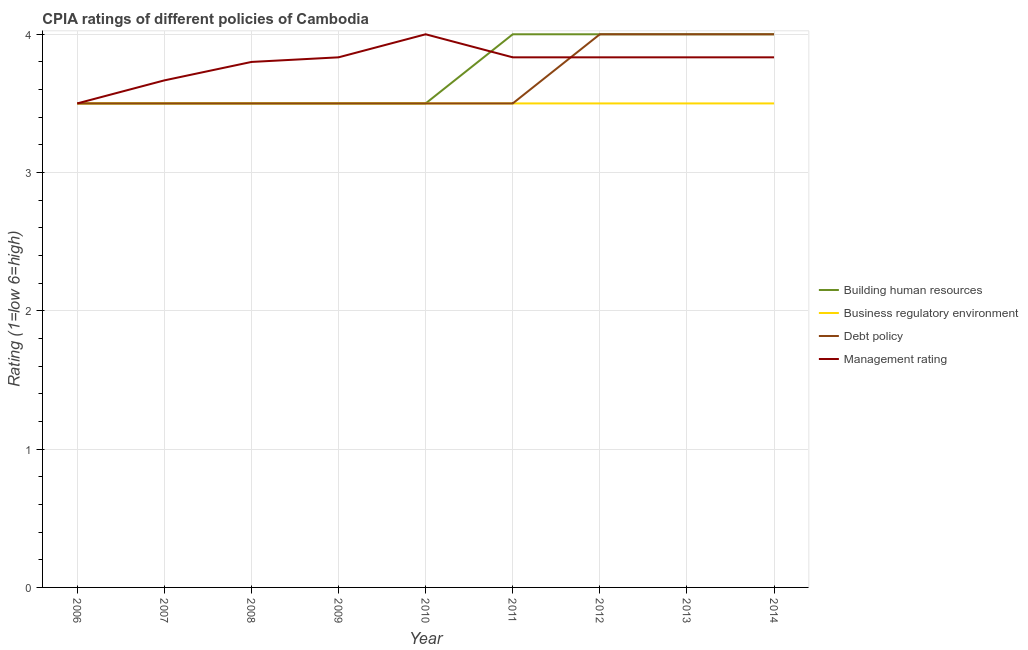How many different coloured lines are there?
Make the answer very short. 4. Is the number of lines equal to the number of legend labels?
Offer a terse response. Yes. What is the cpia rating of management in 2013?
Ensure brevity in your answer.  3.83. Across all years, what is the minimum cpia rating of debt policy?
Your answer should be very brief. 3.5. In which year was the cpia rating of management maximum?
Offer a terse response. 2010. What is the total cpia rating of building human resources in the graph?
Keep it short and to the point. 33.5. What is the difference between the cpia rating of debt policy in 2008 and that in 2013?
Your answer should be very brief. -0.5. What is the average cpia rating of debt policy per year?
Provide a succinct answer. 3.67. In the year 2007, what is the difference between the cpia rating of management and cpia rating of debt policy?
Your answer should be compact. 0.17. What is the ratio of the cpia rating of management in 2006 to that in 2008?
Keep it short and to the point. 0.92. Is the cpia rating of debt policy in 2006 less than that in 2009?
Give a very brief answer. No. Is the difference between the cpia rating of building human resources in 2009 and 2012 greater than the difference between the cpia rating of management in 2009 and 2012?
Your answer should be compact. No. What is the difference between the highest and the second highest cpia rating of building human resources?
Offer a terse response. 0. What is the difference between the highest and the lowest cpia rating of debt policy?
Your response must be concise. 0.5. Is the sum of the cpia rating of management in 2007 and 2009 greater than the maximum cpia rating of business regulatory environment across all years?
Offer a terse response. Yes. Is it the case that in every year, the sum of the cpia rating of building human resources and cpia rating of business regulatory environment is greater than the cpia rating of debt policy?
Your answer should be compact. Yes. Does the cpia rating of building human resources monotonically increase over the years?
Provide a succinct answer. No. Is the cpia rating of business regulatory environment strictly less than the cpia rating of building human resources over the years?
Offer a terse response. No. How many years are there in the graph?
Your answer should be compact. 9. Does the graph contain any zero values?
Provide a succinct answer. No. Where does the legend appear in the graph?
Your response must be concise. Center right. How many legend labels are there?
Your response must be concise. 4. How are the legend labels stacked?
Offer a very short reply. Vertical. What is the title of the graph?
Keep it short and to the point. CPIA ratings of different policies of Cambodia. Does "WFP" appear as one of the legend labels in the graph?
Ensure brevity in your answer.  No. What is the label or title of the X-axis?
Your answer should be compact. Year. What is the Rating (1=low 6=high) of Business regulatory environment in 2006?
Offer a terse response. 3.5. What is the Rating (1=low 6=high) of Business regulatory environment in 2007?
Offer a terse response. 3.5. What is the Rating (1=low 6=high) in Debt policy in 2007?
Provide a short and direct response. 3.5. What is the Rating (1=low 6=high) of Management rating in 2007?
Your answer should be compact. 3.67. What is the Rating (1=low 6=high) of Building human resources in 2008?
Give a very brief answer. 3.5. What is the Rating (1=low 6=high) in Business regulatory environment in 2008?
Offer a terse response. 3.5. What is the Rating (1=low 6=high) of Debt policy in 2008?
Keep it short and to the point. 3.5. What is the Rating (1=low 6=high) of Management rating in 2008?
Your answer should be compact. 3.8. What is the Rating (1=low 6=high) in Building human resources in 2009?
Provide a short and direct response. 3.5. What is the Rating (1=low 6=high) of Debt policy in 2009?
Your answer should be very brief. 3.5. What is the Rating (1=low 6=high) of Management rating in 2009?
Offer a terse response. 3.83. What is the Rating (1=low 6=high) of Debt policy in 2010?
Provide a succinct answer. 3.5. What is the Rating (1=low 6=high) of Business regulatory environment in 2011?
Your answer should be very brief. 3.5. What is the Rating (1=low 6=high) of Debt policy in 2011?
Your answer should be very brief. 3.5. What is the Rating (1=low 6=high) of Management rating in 2011?
Your answer should be very brief. 3.83. What is the Rating (1=low 6=high) of Building human resources in 2012?
Keep it short and to the point. 4. What is the Rating (1=low 6=high) in Business regulatory environment in 2012?
Ensure brevity in your answer.  3.5. What is the Rating (1=low 6=high) in Debt policy in 2012?
Keep it short and to the point. 4. What is the Rating (1=low 6=high) of Management rating in 2012?
Provide a succinct answer. 3.83. What is the Rating (1=low 6=high) in Building human resources in 2013?
Your answer should be very brief. 4. What is the Rating (1=low 6=high) in Business regulatory environment in 2013?
Ensure brevity in your answer.  3.5. What is the Rating (1=low 6=high) of Debt policy in 2013?
Your response must be concise. 4. What is the Rating (1=low 6=high) in Management rating in 2013?
Give a very brief answer. 3.83. What is the Rating (1=low 6=high) in Building human resources in 2014?
Offer a very short reply. 4. What is the Rating (1=low 6=high) in Debt policy in 2014?
Your answer should be very brief. 4. What is the Rating (1=low 6=high) of Management rating in 2014?
Your response must be concise. 3.83. Across all years, what is the maximum Rating (1=low 6=high) of Business regulatory environment?
Ensure brevity in your answer.  3.5. Across all years, what is the maximum Rating (1=low 6=high) of Debt policy?
Offer a very short reply. 4. Across all years, what is the maximum Rating (1=low 6=high) of Management rating?
Ensure brevity in your answer.  4. Across all years, what is the minimum Rating (1=low 6=high) of Building human resources?
Make the answer very short. 3.5. Across all years, what is the minimum Rating (1=low 6=high) in Business regulatory environment?
Offer a terse response. 3.5. Across all years, what is the minimum Rating (1=low 6=high) of Debt policy?
Keep it short and to the point. 3.5. What is the total Rating (1=low 6=high) in Building human resources in the graph?
Keep it short and to the point. 33.5. What is the total Rating (1=low 6=high) in Business regulatory environment in the graph?
Your answer should be very brief. 31.5. What is the total Rating (1=low 6=high) of Management rating in the graph?
Give a very brief answer. 34.13. What is the difference between the Rating (1=low 6=high) of Building human resources in 2006 and that in 2007?
Keep it short and to the point. 0. What is the difference between the Rating (1=low 6=high) in Business regulatory environment in 2006 and that in 2007?
Offer a terse response. 0. What is the difference between the Rating (1=low 6=high) of Management rating in 2006 and that in 2007?
Your answer should be compact. -0.17. What is the difference between the Rating (1=low 6=high) of Business regulatory environment in 2006 and that in 2008?
Keep it short and to the point. 0. What is the difference between the Rating (1=low 6=high) in Debt policy in 2006 and that in 2008?
Provide a short and direct response. 0. What is the difference between the Rating (1=low 6=high) of Building human resources in 2006 and that in 2009?
Give a very brief answer. 0. What is the difference between the Rating (1=low 6=high) in Business regulatory environment in 2006 and that in 2009?
Make the answer very short. 0. What is the difference between the Rating (1=low 6=high) of Business regulatory environment in 2006 and that in 2010?
Keep it short and to the point. 0. What is the difference between the Rating (1=low 6=high) in Debt policy in 2006 and that in 2010?
Make the answer very short. 0. What is the difference between the Rating (1=low 6=high) of Management rating in 2006 and that in 2010?
Provide a short and direct response. -0.5. What is the difference between the Rating (1=low 6=high) in Building human resources in 2006 and that in 2011?
Ensure brevity in your answer.  -0.5. What is the difference between the Rating (1=low 6=high) in Debt policy in 2006 and that in 2011?
Make the answer very short. 0. What is the difference between the Rating (1=low 6=high) of Debt policy in 2006 and that in 2012?
Offer a very short reply. -0.5. What is the difference between the Rating (1=low 6=high) of Management rating in 2006 and that in 2012?
Your response must be concise. -0.33. What is the difference between the Rating (1=low 6=high) of Debt policy in 2006 and that in 2013?
Your answer should be compact. -0.5. What is the difference between the Rating (1=low 6=high) of Management rating in 2006 and that in 2014?
Your response must be concise. -0.33. What is the difference between the Rating (1=low 6=high) in Building human resources in 2007 and that in 2008?
Give a very brief answer. 0. What is the difference between the Rating (1=low 6=high) in Debt policy in 2007 and that in 2008?
Your response must be concise. 0. What is the difference between the Rating (1=low 6=high) in Management rating in 2007 and that in 2008?
Provide a succinct answer. -0.13. What is the difference between the Rating (1=low 6=high) in Debt policy in 2007 and that in 2009?
Your answer should be very brief. 0. What is the difference between the Rating (1=low 6=high) in Building human resources in 2007 and that in 2010?
Keep it short and to the point. 0. What is the difference between the Rating (1=low 6=high) of Management rating in 2007 and that in 2010?
Your answer should be compact. -0.33. What is the difference between the Rating (1=low 6=high) of Business regulatory environment in 2007 and that in 2011?
Keep it short and to the point. 0. What is the difference between the Rating (1=low 6=high) in Debt policy in 2007 and that in 2011?
Provide a succinct answer. 0. What is the difference between the Rating (1=low 6=high) in Management rating in 2007 and that in 2011?
Your answer should be very brief. -0.17. What is the difference between the Rating (1=low 6=high) of Business regulatory environment in 2007 and that in 2012?
Offer a very short reply. 0. What is the difference between the Rating (1=low 6=high) of Debt policy in 2007 and that in 2012?
Your answer should be very brief. -0.5. What is the difference between the Rating (1=low 6=high) of Management rating in 2007 and that in 2012?
Provide a succinct answer. -0.17. What is the difference between the Rating (1=low 6=high) of Building human resources in 2007 and that in 2013?
Keep it short and to the point. -0.5. What is the difference between the Rating (1=low 6=high) of Building human resources in 2007 and that in 2014?
Provide a short and direct response. -0.5. What is the difference between the Rating (1=low 6=high) of Business regulatory environment in 2007 and that in 2014?
Ensure brevity in your answer.  0. What is the difference between the Rating (1=low 6=high) of Debt policy in 2007 and that in 2014?
Offer a very short reply. -0.5. What is the difference between the Rating (1=low 6=high) in Business regulatory environment in 2008 and that in 2009?
Make the answer very short. 0. What is the difference between the Rating (1=low 6=high) in Debt policy in 2008 and that in 2009?
Your response must be concise. 0. What is the difference between the Rating (1=low 6=high) in Management rating in 2008 and that in 2009?
Your answer should be very brief. -0.03. What is the difference between the Rating (1=low 6=high) of Building human resources in 2008 and that in 2010?
Provide a succinct answer. 0. What is the difference between the Rating (1=low 6=high) of Debt policy in 2008 and that in 2010?
Your answer should be very brief. 0. What is the difference between the Rating (1=low 6=high) of Management rating in 2008 and that in 2010?
Give a very brief answer. -0.2. What is the difference between the Rating (1=low 6=high) of Business regulatory environment in 2008 and that in 2011?
Make the answer very short. 0. What is the difference between the Rating (1=low 6=high) of Management rating in 2008 and that in 2011?
Provide a short and direct response. -0.03. What is the difference between the Rating (1=low 6=high) in Building human resources in 2008 and that in 2012?
Your response must be concise. -0.5. What is the difference between the Rating (1=low 6=high) in Business regulatory environment in 2008 and that in 2012?
Your response must be concise. 0. What is the difference between the Rating (1=low 6=high) of Management rating in 2008 and that in 2012?
Offer a terse response. -0.03. What is the difference between the Rating (1=low 6=high) of Management rating in 2008 and that in 2013?
Your response must be concise. -0.03. What is the difference between the Rating (1=low 6=high) of Management rating in 2008 and that in 2014?
Provide a succinct answer. -0.03. What is the difference between the Rating (1=low 6=high) of Building human resources in 2009 and that in 2010?
Your answer should be compact. 0. What is the difference between the Rating (1=low 6=high) of Business regulatory environment in 2009 and that in 2010?
Your answer should be compact. 0. What is the difference between the Rating (1=low 6=high) in Debt policy in 2009 and that in 2010?
Provide a succinct answer. 0. What is the difference between the Rating (1=low 6=high) of Management rating in 2009 and that in 2010?
Offer a very short reply. -0.17. What is the difference between the Rating (1=low 6=high) in Building human resources in 2009 and that in 2011?
Offer a terse response. -0.5. What is the difference between the Rating (1=low 6=high) in Business regulatory environment in 2009 and that in 2011?
Give a very brief answer. 0. What is the difference between the Rating (1=low 6=high) of Building human resources in 2009 and that in 2012?
Offer a very short reply. -0.5. What is the difference between the Rating (1=low 6=high) in Business regulatory environment in 2009 and that in 2013?
Offer a terse response. 0. What is the difference between the Rating (1=low 6=high) in Business regulatory environment in 2009 and that in 2014?
Ensure brevity in your answer.  0. What is the difference between the Rating (1=low 6=high) of Management rating in 2010 and that in 2011?
Your answer should be compact. 0.17. What is the difference between the Rating (1=low 6=high) of Building human resources in 2010 and that in 2012?
Offer a very short reply. -0.5. What is the difference between the Rating (1=low 6=high) in Business regulatory environment in 2010 and that in 2012?
Your answer should be compact. 0. What is the difference between the Rating (1=low 6=high) of Debt policy in 2010 and that in 2012?
Your answer should be very brief. -0.5. What is the difference between the Rating (1=low 6=high) in Management rating in 2010 and that in 2012?
Offer a very short reply. 0.17. What is the difference between the Rating (1=low 6=high) in Debt policy in 2010 and that in 2013?
Make the answer very short. -0.5. What is the difference between the Rating (1=low 6=high) in Management rating in 2010 and that in 2013?
Your answer should be compact. 0.17. What is the difference between the Rating (1=low 6=high) in Business regulatory environment in 2010 and that in 2014?
Offer a very short reply. 0. What is the difference between the Rating (1=low 6=high) in Management rating in 2010 and that in 2014?
Ensure brevity in your answer.  0.17. What is the difference between the Rating (1=low 6=high) of Business regulatory environment in 2011 and that in 2012?
Make the answer very short. 0. What is the difference between the Rating (1=low 6=high) in Debt policy in 2011 and that in 2012?
Offer a very short reply. -0.5. What is the difference between the Rating (1=low 6=high) in Building human resources in 2011 and that in 2013?
Make the answer very short. 0. What is the difference between the Rating (1=low 6=high) in Business regulatory environment in 2011 and that in 2013?
Give a very brief answer. 0. What is the difference between the Rating (1=low 6=high) of Debt policy in 2011 and that in 2013?
Make the answer very short. -0.5. What is the difference between the Rating (1=low 6=high) of Management rating in 2011 and that in 2013?
Provide a succinct answer. 0. What is the difference between the Rating (1=low 6=high) of Building human resources in 2012 and that in 2013?
Offer a very short reply. 0. What is the difference between the Rating (1=low 6=high) in Business regulatory environment in 2012 and that in 2013?
Give a very brief answer. 0. What is the difference between the Rating (1=low 6=high) of Debt policy in 2012 and that in 2013?
Ensure brevity in your answer.  0. What is the difference between the Rating (1=low 6=high) of Management rating in 2012 and that in 2013?
Your response must be concise. 0. What is the difference between the Rating (1=low 6=high) of Building human resources in 2012 and that in 2014?
Give a very brief answer. 0. What is the difference between the Rating (1=low 6=high) of Business regulatory environment in 2012 and that in 2014?
Your response must be concise. 0. What is the difference between the Rating (1=low 6=high) in Building human resources in 2013 and that in 2014?
Provide a succinct answer. 0. What is the difference between the Rating (1=low 6=high) of Business regulatory environment in 2013 and that in 2014?
Keep it short and to the point. 0. What is the difference between the Rating (1=low 6=high) in Management rating in 2013 and that in 2014?
Keep it short and to the point. 0. What is the difference between the Rating (1=low 6=high) of Building human resources in 2006 and the Rating (1=low 6=high) of Business regulatory environment in 2007?
Your response must be concise. 0. What is the difference between the Rating (1=low 6=high) in Building human resources in 2006 and the Rating (1=low 6=high) in Management rating in 2007?
Ensure brevity in your answer.  -0.17. What is the difference between the Rating (1=low 6=high) of Debt policy in 2006 and the Rating (1=low 6=high) of Management rating in 2007?
Give a very brief answer. -0.17. What is the difference between the Rating (1=low 6=high) of Business regulatory environment in 2006 and the Rating (1=low 6=high) of Debt policy in 2008?
Provide a short and direct response. 0. What is the difference between the Rating (1=low 6=high) of Business regulatory environment in 2006 and the Rating (1=low 6=high) of Management rating in 2008?
Offer a very short reply. -0.3. What is the difference between the Rating (1=low 6=high) of Debt policy in 2006 and the Rating (1=low 6=high) of Management rating in 2008?
Your answer should be very brief. -0.3. What is the difference between the Rating (1=low 6=high) of Building human resources in 2006 and the Rating (1=low 6=high) of Business regulatory environment in 2009?
Offer a terse response. 0. What is the difference between the Rating (1=low 6=high) of Building human resources in 2006 and the Rating (1=low 6=high) of Management rating in 2009?
Make the answer very short. -0.33. What is the difference between the Rating (1=low 6=high) of Debt policy in 2006 and the Rating (1=low 6=high) of Management rating in 2009?
Provide a short and direct response. -0.33. What is the difference between the Rating (1=low 6=high) of Building human resources in 2006 and the Rating (1=low 6=high) of Business regulatory environment in 2010?
Your answer should be very brief. 0. What is the difference between the Rating (1=low 6=high) of Building human resources in 2006 and the Rating (1=low 6=high) of Debt policy in 2010?
Give a very brief answer. 0. What is the difference between the Rating (1=low 6=high) in Building human resources in 2006 and the Rating (1=low 6=high) in Management rating in 2010?
Provide a succinct answer. -0.5. What is the difference between the Rating (1=low 6=high) in Business regulatory environment in 2006 and the Rating (1=low 6=high) in Debt policy in 2010?
Offer a very short reply. 0. What is the difference between the Rating (1=low 6=high) in Business regulatory environment in 2006 and the Rating (1=low 6=high) in Management rating in 2010?
Provide a short and direct response. -0.5. What is the difference between the Rating (1=low 6=high) of Debt policy in 2006 and the Rating (1=low 6=high) of Management rating in 2010?
Give a very brief answer. -0.5. What is the difference between the Rating (1=low 6=high) of Building human resources in 2006 and the Rating (1=low 6=high) of Business regulatory environment in 2011?
Your answer should be compact. 0. What is the difference between the Rating (1=low 6=high) in Building human resources in 2006 and the Rating (1=low 6=high) in Debt policy in 2011?
Provide a succinct answer. 0. What is the difference between the Rating (1=low 6=high) in Debt policy in 2006 and the Rating (1=low 6=high) in Management rating in 2012?
Your response must be concise. -0.33. What is the difference between the Rating (1=low 6=high) of Building human resources in 2006 and the Rating (1=low 6=high) of Debt policy in 2013?
Give a very brief answer. -0.5. What is the difference between the Rating (1=low 6=high) of Building human resources in 2006 and the Rating (1=low 6=high) of Management rating in 2013?
Ensure brevity in your answer.  -0.33. What is the difference between the Rating (1=low 6=high) of Business regulatory environment in 2006 and the Rating (1=low 6=high) of Debt policy in 2013?
Ensure brevity in your answer.  -0.5. What is the difference between the Rating (1=low 6=high) in Business regulatory environment in 2006 and the Rating (1=low 6=high) in Management rating in 2013?
Ensure brevity in your answer.  -0.33. What is the difference between the Rating (1=low 6=high) in Building human resources in 2006 and the Rating (1=low 6=high) in Debt policy in 2014?
Offer a very short reply. -0.5. What is the difference between the Rating (1=low 6=high) of Building human resources in 2006 and the Rating (1=low 6=high) of Management rating in 2014?
Keep it short and to the point. -0.33. What is the difference between the Rating (1=low 6=high) of Business regulatory environment in 2006 and the Rating (1=low 6=high) of Management rating in 2014?
Ensure brevity in your answer.  -0.33. What is the difference between the Rating (1=low 6=high) in Building human resources in 2007 and the Rating (1=low 6=high) in Debt policy in 2008?
Offer a terse response. 0. What is the difference between the Rating (1=low 6=high) of Building human resources in 2007 and the Rating (1=low 6=high) of Management rating in 2008?
Keep it short and to the point. -0.3. What is the difference between the Rating (1=low 6=high) in Business regulatory environment in 2007 and the Rating (1=low 6=high) in Management rating in 2008?
Your response must be concise. -0.3. What is the difference between the Rating (1=low 6=high) in Debt policy in 2007 and the Rating (1=low 6=high) in Management rating in 2008?
Your answer should be compact. -0.3. What is the difference between the Rating (1=low 6=high) in Building human resources in 2007 and the Rating (1=low 6=high) in Management rating in 2009?
Ensure brevity in your answer.  -0.33. What is the difference between the Rating (1=low 6=high) in Business regulatory environment in 2007 and the Rating (1=low 6=high) in Management rating in 2009?
Provide a short and direct response. -0.33. What is the difference between the Rating (1=low 6=high) of Debt policy in 2007 and the Rating (1=low 6=high) of Management rating in 2009?
Keep it short and to the point. -0.33. What is the difference between the Rating (1=low 6=high) of Building human resources in 2007 and the Rating (1=low 6=high) of Debt policy in 2010?
Provide a succinct answer. 0. What is the difference between the Rating (1=low 6=high) in Business regulatory environment in 2007 and the Rating (1=low 6=high) in Management rating in 2010?
Offer a very short reply. -0.5. What is the difference between the Rating (1=low 6=high) of Debt policy in 2007 and the Rating (1=low 6=high) of Management rating in 2010?
Your response must be concise. -0.5. What is the difference between the Rating (1=low 6=high) of Building human resources in 2007 and the Rating (1=low 6=high) of Business regulatory environment in 2011?
Your answer should be compact. 0. What is the difference between the Rating (1=low 6=high) of Building human resources in 2007 and the Rating (1=low 6=high) of Management rating in 2011?
Keep it short and to the point. -0.33. What is the difference between the Rating (1=low 6=high) in Business regulatory environment in 2007 and the Rating (1=low 6=high) in Management rating in 2011?
Your response must be concise. -0.33. What is the difference between the Rating (1=low 6=high) in Debt policy in 2007 and the Rating (1=low 6=high) in Management rating in 2011?
Offer a terse response. -0.33. What is the difference between the Rating (1=low 6=high) of Building human resources in 2007 and the Rating (1=low 6=high) of Business regulatory environment in 2012?
Your response must be concise. 0. What is the difference between the Rating (1=low 6=high) of Building human resources in 2007 and the Rating (1=low 6=high) of Management rating in 2012?
Offer a terse response. -0.33. What is the difference between the Rating (1=low 6=high) in Business regulatory environment in 2007 and the Rating (1=low 6=high) in Management rating in 2012?
Offer a very short reply. -0.33. What is the difference between the Rating (1=low 6=high) of Debt policy in 2007 and the Rating (1=low 6=high) of Management rating in 2012?
Ensure brevity in your answer.  -0.33. What is the difference between the Rating (1=low 6=high) of Building human resources in 2007 and the Rating (1=low 6=high) of Management rating in 2013?
Make the answer very short. -0.33. What is the difference between the Rating (1=low 6=high) in Business regulatory environment in 2007 and the Rating (1=low 6=high) in Management rating in 2013?
Keep it short and to the point. -0.33. What is the difference between the Rating (1=low 6=high) of Debt policy in 2007 and the Rating (1=low 6=high) of Management rating in 2013?
Offer a terse response. -0.33. What is the difference between the Rating (1=low 6=high) in Building human resources in 2007 and the Rating (1=low 6=high) in Debt policy in 2014?
Your answer should be very brief. -0.5. What is the difference between the Rating (1=low 6=high) in Building human resources in 2008 and the Rating (1=low 6=high) in Business regulatory environment in 2009?
Offer a terse response. 0. What is the difference between the Rating (1=low 6=high) in Business regulatory environment in 2008 and the Rating (1=low 6=high) in Management rating in 2010?
Offer a very short reply. -0.5. What is the difference between the Rating (1=low 6=high) of Debt policy in 2008 and the Rating (1=low 6=high) of Management rating in 2010?
Give a very brief answer. -0.5. What is the difference between the Rating (1=low 6=high) in Building human resources in 2008 and the Rating (1=low 6=high) in Business regulatory environment in 2011?
Your answer should be very brief. 0. What is the difference between the Rating (1=low 6=high) of Business regulatory environment in 2008 and the Rating (1=low 6=high) of Debt policy in 2011?
Make the answer very short. 0. What is the difference between the Rating (1=low 6=high) in Business regulatory environment in 2008 and the Rating (1=low 6=high) in Management rating in 2011?
Ensure brevity in your answer.  -0.33. What is the difference between the Rating (1=low 6=high) in Debt policy in 2008 and the Rating (1=low 6=high) in Management rating in 2011?
Give a very brief answer. -0.33. What is the difference between the Rating (1=low 6=high) of Building human resources in 2008 and the Rating (1=low 6=high) of Debt policy in 2012?
Give a very brief answer. -0.5. What is the difference between the Rating (1=low 6=high) of Debt policy in 2008 and the Rating (1=low 6=high) of Management rating in 2012?
Offer a very short reply. -0.33. What is the difference between the Rating (1=low 6=high) in Building human resources in 2008 and the Rating (1=low 6=high) in Business regulatory environment in 2013?
Make the answer very short. 0. What is the difference between the Rating (1=low 6=high) in Building human resources in 2008 and the Rating (1=low 6=high) in Debt policy in 2013?
Your answer should be very brief. -0.5. What is the difference between the Rating (1=low 6=high) in Business regulatory environment in 2008 and the Rating (1=low 6=high) in Debt policy in 2013?
Your response must be concise. -0.5. What is the difference between the Rating (1=low 6=high) of Building human resources in 2008 and the Rating (1=low 6=high) of Business regulatory environment in 2014?
Make the answer very short. 0. What is the difference between the Rating (1=low 6=high) of Building human resources in 2008 and the Rating (1=low 6=high) of Debt policy in 2014?
Keep it short and to the point. -0.5. What is the difference between the Rating (1=low 6=high) in Business regulatory environment in 2008 and the Rating (1=low 6=high) in Debt policy in 2014?
Provide a succinct answer. -0.5. What is the difference between the Rating (1=low 6=high) of Business regulatory environment in 2008 and the Rating (1=low 6=high) of Management rating in 2014?
Provide a succinct answer. -0.33. What is the difference between the Rating (1=low 6=high) of Debt policy in 2008 and the Rating (1=low 6=high) of Management rating in 2014?
Offer a very short reply. -0.33. What is the difference between the Rating (1=low 6=high) in Building human resources in 2009 and the Rating (1=low 6=high) in Management rating in 2010?
Provide a succinct answer. -0.5. What is the difference between the Rating (1=low 6=high) in Business regulatory environment in 2009 and the Rating (1=low 6=high) in Management rating in 2010?
Keep it short and to the point. -0.5. What is the difference between the Rating (1=low 6=high) in Building human resources in 2009 and the Rating (1=low 6=high) in Debt policy in 2011?
Provide a short and direct response. 0. What is the difference between the Rating (1=low 6=high) of Business regulatory environment in 2009 and the Rating (1=low 6=high) of Debt policy in 2011?
Provide a short and direct response. 0. What is the difference between the Rating (1=low 6=high) in Building human resources in 2009 and the Rating (1=low 6=high) in Management rating in 2012?
Ensure brevity in your answer.  -0.33. What is the difference between the Rating (1=low 6=high) in Business regulatory environment in 2009 and the Rating (1=low 6=high) in Debt policy in 2013?
Your answer should be very brief. -0.5. What is the difference between the Rating (1=low 6=high) in Debt policy in 2009 and the Rating (1=low 6=high) in Management rating in 2013?
Your response must be concise. -0.33. What is the difference between the Rating (1=low 6=high) in Building human resources in 2009 and the Rating (1=low 6=high) in Debt policy in 2014?
Keep it short and to the point. -0.5. What is the difference between the Rating (1=low 6=high) in Debt policy in 2009 and the Rating (1=low 6=high) in Management rating in 2014?
Make the answer very short. -0.33. What is the difference between the Rating (1=low 6=high) of Building human resources in 2010 and the Rating (1=low 6=high) of Business regulatory environment in 2011?
Provide a succinct answer. 0. What is the difference between the Rating (1=low 6=high) of Building human resources in 2010 and the Rating (1=low 6=high) of Management rating in 2011?
Your answer should be compact. -0.33. What is the difference between the Rating (1=low 6=high) of Business regulatory environment in 2010 and the Rating (1=low 6=high) of Debt policy in 2011?
Your answer should be compact. 0. What is the difference between the Rating (1=low 6=high) of Business regulatory environment in 2010 and the Rating (1=low 6=high) of Management rating in 2011?
Your answer should be compact. -0.33. What is the difference between the Rating (1=low 6=high) of Debt policy in 2010 and the Rating (1=low 6=high) of Management rating in 2011?
Your answer should be compact. -0.33. What is the difference between the Rating (1=low 6=high) in Building human resources in 2010 and the Rating (1=low 6=high) in Debt policy in 2012?
Give a very brief answer. -0.5. What is the difference between the Rating (1=low 6=high) of Building human resources in 2010 and the Rating (1=low 6=high) of Management rating in 2012?
Give a very brief answer. -0.33. What is the difference between the Rating (1=low 6=high) in Business regulatory environment in 2010 and the Rating (1=low 6=high) in Debt policy in 2012?
Offer a terse response. -0.5. What is the difference between the Rating (1=low 6=high) in Debt policy in 2010 and the Rating (1=low 6=high) in Management rating in 2012?
Provide a succinct answer. -0.33. What is the difference between the Rating (1=low 6=high) of Building human resources in 2010 and the Rating (1=low 6=high) of Business regulatory environment in 2013?
Keep it short and to the point. 0. What is the difference between the Rating (1=low 6=high) of Business regulatory environment in 2010 and the Rating (1=low 6=high) of Debt policy in 2013?
Your response must be concise. -0.5. What is the difference between the Rating (1=low 6=high) in Building human resources in 2010 and the Rating (1=low 6=high) in Debt policy in 2014?
Keep it short and to the point. -0.5. What is the difference between the Rating (1=low 6=high) in Business regulatory environment in 2010 and the Rating (1=low 6=high) in Debt policy in 2014?
Provide a short and direct response. -0.5. What is the difference between the Rating (1=low 6=high) in Building human resources in 2011 and the Rating (1=low 6=high) in Management rating in 2012?
Give a very brief answer. 0.17. What is the difference between the Rating (1=low 6=high) of Business regulatory environment in 2011 and the Rating (1=low 6=high) of Management rating in 2012?
Give a very brief answer. -0.33. What is the difference between the Rating (1=low 6=high) in Building human resources in 2011 and the Rating (1=low 6=high) in Business regulatory environment in 2013?
Provide a succinct answer. 0.5. What is the difference between the Rating (1=low 6=high) of Building human resources in 2011 and the Rating (1=low 6=high) of Debt policy in 2013?
Offer a very short reply. 0. What is the difference between the Rating (1=low 6=high) of Debt policy in 2011 and the Rating (1=low 6=high) of Management rating in 2013?
Keep it short and to the point. -0.33. What is the difference between the Rating (1=low 6=high) of Building human resources in 2011 and the Rating (1=low 6=high) of Business regulatory environment in 2014?
Your answer should be very brief. 0.5. What is the difference between the Rating (1=low 6=high) of Building human resources in 2011 and the Rating (1=low 6=high) of Management rating in 2014?
Provide a short and direct response. 0.17. What is the difference between the Rating (1=low 6=high) of Business regulatory environment in 2011 and the Rating (1=low 6=high) of Debt policy in 2014?
Your answer should be compact. -0.5. What is the difference between the Rating (1=low 6=high) in Debt policy in 2011 and the Rating (1=low 6=high) in Management rating in 2014?
Offer a terse response. -0.33. What is the difference between the Rating (1=low 6=high) of Building human resources in 2012 and the Rating (1=low 6=high) of Business regulatory environment in 2013?
Offer a very short reply. 0.5. What is the difference between the Rating (1=low 6=high) of Building human resources in 2012 and the Rating (1=low 6=high) of Debt policy in 2013?
Your response must be concise. 0. What is the difference between the Rating (1=low 6=high) of Business regulatory environment in 2012 and the Rating (1=low 6=high) of Debt policy in 2013?
Offer a very short reply. -0.5. What is the difference between the Rating (1=low 6=high) in Debt policy in 2012 and the Rating (1=low 6=high) in Management rating in 2013?
Ensure brevity in your answer.  0.17. What is the difference between the Rating (1=low 6=high) in Building human resources in 2012 and the Rating (1=low 6=high) in Business regulatory environment in 2014?
Offer a very short reply. 0.5. What is the difference between the Rating (1=low 6=high) of Building human resources in 2013 and the Rating (1=low 6=high) of Business regulatory environment in 2014?
Ensure brevity in your answer.  0.5. What is the difference between the Rating (1=low 6=high) of Business regulatory environment in 2013 and the Rating (1=low 6=high) of Management rating in 2014?
Make the answer very short. -0.33. What is the difference between the Rating (1=low 6=high) in Debt policy in 2013 and the Rating (1=low 6=high) in Management rating in 2014?
Give a very brief answer. 0.17. What is the average Rating (1=low 6=high) of Building human resources per year?
Ensure brevity in your answer.  3.72. What is the average Rating (1=low 6=high) in Business regulatory environment per year?
Offer a very short reply. 3.5. What is the average Rating (1=low 6=high) in Debt policy per year?
Give a very brief answer. 3.67. What is the average Rating (1=low 6=high) of Management rating per year?
Give a very brief answer. 3.79. In the year 2006, what is the difference between the Rating (1=low 6=high) of Building human resources and Rating (1=low 6=high) of Business regulatory environment?
Ensure brevity in your answer.  0. In the year 2006, what is the difference between the Rating (1=low 6=high) of Building human resources and Rating (1=low 6=high) of Debt policy?
Your answer should be compact. 0. In the year 2006, what is the difference between the Rating (1=low 6=high) in Building human resources and Rating (1=low 6=high) in Management rating?
Provide a succinct answer. 0. In the year 2006, what is the difference between the Rating (1=low 6=high) in Business regulatory environment and Rating (1=low 6=high) in Debt policy?
Give a very brief answer. 0. In the year 2006, what is the difference between the Rating (1=low 6=high) in Business regulatory environment and Rating (1=low 6=high) in Management rating?
Give a very brief answer. 0. In the year 2007, what is the difference between the Rating (1=low 6=high) of Building human resources and Rating (1=low 6=high) of Debt policy?
Offer a terse response. 0. In the year 2007, what is the difference between the Rating (1=low 6=high) in Building human resources and Rating (1=low 6=high) in Management rating?
Your answer should be compact. -0.17. In the year 2007, what is the difference between the Rating (1=low 6=high) of Business regulatory environment and Rating (1=low 6=high) of Debt policy?
Provide a succinct answer. 0. In the year 2007, what is the difference between the Rating (1=low 6=high) of Business regulatory environment and Rating (1=low 6=high) of Management rating?
Keep it short and to the point. -0.17. In the year 2007, what is the difference between the Rating (1=low 6=high) in Debt policy and Rating (1=low 6=high) in Management rating?
Provide a succinct answer. -0.17. In the year 2008, what is the difference between the Rating (1=low 6=high) of Building human resources and Rating (1=low 6=high) of Business regulatory environment?
Give a very brief answer. 0. In the year 2008, what is the difference between the Rating (1=low 6=high) in Building human resources and Rating (1=low 6=high) in Debt policy?
Your answer should be compact. 0. In the year 2008, what is the difference between the Rating (1=low 6=high) of Building human resources and Rating (1=low 6=high) of Management rating?
Offer a terse response. -0.3. In the year 2008, what is the difference between the Rating (1=low 6=high) of Business regulatory environment and Rating (1=low 6=high) of Debt policy?
Your answer should be compact. 0. In the year 2008, what is the difference between the Rating (1=low 6=high) in Business regulatory environment and Rating (1=low 6=high) in Management rating?
Provide a succinct answer. -0.3. In the year 2008, what is the difference between the Rating (1=low 6=high) of Debt policy and Rating (1=low 6=high) of Management rating?
Offer a very short reply. -0.3. In the year 2009, what is the difference between the Rating (1=low 6=high) in Building human resources and Rating (1=low 6=high) in Business regulatory environment?
Your response must be concise. 0. In the year 2009, what is the difference between the Rating (1=low 6=high) of Building human resources and Rating (1=low 6=high) of Management rating?
Your answer should be very brief. -0.33. In the year 2009, what is the difference between the Rating (1=low 6=high) in Business regulatory environment and Rating (1=low 6=high) in Debt policy?
Give a very brief answer. 0. In the year 2009, what is the difference between the Rating (1=low 6=high) of Business regulatory environment and Rating (1=low 6=high) of Management rating?
Give a very brief answer. -0.33. In the year 2009, what is the difference between the Rating (1=low 6=high) of Debt policy and Rating (1=low 6=high) of Management rating?
Provide a short and direct response. -0.33. In the year 2010, what is the difference between the Rating (1=low 6=high) in Building human resources and Rating (1=low 6=high) in Business regulatory environment?
Offer a terse response. 0. In the year 2010, what is the difference between the Rating (1=low 6=high) in Business regulatory environment and Rating (1=low 6=high) in Management rating?
Provide a succinct answer. -0.5. In the year 2010, what is the difference between the Rating (1=low 6=high) of Debt policy and Rating (1=low 6=high) of Management rating?
Ensure brevity in your answer.  -0.5. In the year 2011, what is the difference between the Rating (1=low 6=high) of Building human resources and Rating (1=low 6=high) of Management rating?
Your response must be concise. 0.17. In the year 2011, what is the difference between the Rating (1=low 6=high) in Business regulatory environment and Rating (1=low 6=high) in Debt policy?
Your response must be concise. 0. In the year 2011, what is the difference between the Rating (1=low 6=high) of Business regulatory environment and Rating (1=low 6=high) of Management rating?
Your answer should be compact. -0.33. In the year 2012, what is the difference between the Rating (1=low 6=high) in Building human resources and Rating (1=low 6=high) in Business regulatory environment?
Your response must be concise. 0.5. In the year 2012, what is the difference between the Rating (1=low 6=high) of Building human resources and Rating (1=low 6=high) of Debt policy?
Make the answer very short. 0. In the year 2012, what is the difference between the Rating (1=low 6=high) in Building human resources and Rating (1=low 6=high) in Management rating?
Provide a succinct answer. 0.17. In the year 2013, what is the difference between the Rating (1=low 6=high) in Building human resources and Rating (1=low 6=high) in Debt policy?
Make the answer very short. 0. In the year 2013, what is the difference between the Rating (1=low 6=high) of Building human resources and Rating (1=low 6=high) of Management rating?
Give a very brief answer. 0.17. In the year 2014, what is the difference between the Rating (1=low 6=high) of Building human resources and Rating (1=low 6=high) of Business regulatory environment?
Provide a succinct answer. 0.5. In the year 2014, what is the difference between the Rating (1=low 6=high) in Business regulatory environment and Rating (1=low 6=high) in Management rating?
Give a very brief answer. -0.33. In the year 2014, what is the difference between the Rating (1=low 6=high) of Debt policy and Rating (1=low 6=high) of Management rating?
Ensure brevity in your answer.  0.17. What is the ratio of the Rating (1=low 6=high) of Building human resources in 2006 to that in 2007?
Your answer should be very brief. 1. What is the ratio of the Rating (1=low 6=high) in Business regulatory environment in 2006 to that in 2007?
Keep it short and to the point. 1. What is the ratio of the Rating (1=low 6=high) of Management rating in 2006 to that in 2007?
Provide a succinct answer. 0.95. What is the ratio of the Rating (1=low 6=high) in Debt policy in 2006 to that in 2008?
Offer a very short reply. 1. What is the ratio of the Rating (1=low 6=high) in Management rating in 2006 to that in 2008?
Make the answer very short. 0.92. What is the ratio of the Rating (1=low 6=high) of Building human resources in 2006 to that in 2009?
Your response must be concise. 1. What is the ratio of the Rating (1=low 6=high) of Business regulatory environment in 2006 to that in 2009?
Provide a short and direct response. 1. What is the ratio of the Rating (1=low 6=high) in Debt policy in 2006 to that in 2009?
Your response must be concise. 1. What is the ratio of the Rating (1=low 6=high) of Building human resources in 2006 to that in 2011?
Keep it short and to the point. 0.88. What is the ratio of the Rating (1=low 6=high) in Business regulatory environment in 2006 to that in 2011?
Provide a succinct answer. 1. What is the ratio of the Rating (1=low 6=high) of Management rating in 2006 to that in 2011?
Offer a terse response. 0.91. What is the ratio of the Rating (1=low 6=high) of Business regulatory environment in 2006 to that in 2012?
Keep it short and to the point. 1. What is the ratio of the Rating (1=low 6=high) in Debt policy in 2006 to that in 2012?
Your answer should be very brief. 0.88. What is the ratio of the Rating (1=low 6=high) of Building human resources in 2006 to that in 2013?
Your answer should be very brief. 0.88. What is the ratio of the Rating (1=low 6=high) in Business regulatory environment in 2006 to that in 2013?
Keep it short and to the point. 1. What is the ratio of the Rating (1=low 6=high) in Debt policy in 2006 to that in 2013?
Offer a very short reply. 0.88. What is the ratio of the Rating (1=low 6=high) of Management rating in 2006 to that in 2013?
Give a very brief answer. 0.91. What is the ratio of the Rating (1=low 6=high) of Building human resources in 2006 to that in 2014?
Provide a succinct answer. 0.88. What is the ratio of the Rating (1=low 6=high) of Building human resources in 2007 to that in 2008?
Your answer should be very brief. 1. What is the ratio of the Rating (1=low 6=high) of Debt policy in 2007 to that in 2008?
Your answer should be very brief. 1. What is the ratio of the Rating (1=low 6=high) in Management rating in 2007 to that in 2008?
Offer a very short reply. 0.96. What is the ratio of the Rating (1=low 6=high) in Building human resources in 2007 to that in 2009?
Ensure brevity in your answer.  1. What is the ratio of the Rating (1=low 6=high) in Business regulatory environment in 2007 to that in 2009?
Offer a very short reply. 1. What is the ratio of the Rating (1=low 6=high) of Debt policy in 2007 to that in 2009?
Keep it short and to the point. 1. What is the ratio of the Rating (1=low 6=high) in Management rating in 2007 to that in 2009?
Offer a very short reply. 0.96. What is the ratio of the Rating (1=low 6=high) in Business regulatory environment in 2007 to that in 2010?
Your response must be concise. 1. What is the ratio of the Rating (1=low 6=high) in Management rating in 2007 to that in 2010?
Provide a short and direct response. 0.92. What is the ratio of the Rating (1=low 6=high) of Business regulatory environment in 2007 to that in 2011?
Make the answer very short. 1. What is the ratio of the Rating (1=low 6=high) of Management rating in 2007 to that in 2011?
Offer a terse response. 0.96. What is the ratio of the Rating (1=low 6=high) of Business regulatory environment in 2007 to that in 2012?
Your answer should be very brief. 1. What is the ratio of the Rating (1=low 6=high) in Debt policy in 2007 to that in 2012?
Give a very brief answer. 0.88. What is the ratio of the Rating (1=low 6=high) in Management rating in 2007 to that in 2012?
Give a very brief answer. 0.96. What is the ratio of the Rating (1=low 6=high) of Building human resources in 2007 to that in 2013?
Ensure brevity in your answer.  0.88. What is the ratio of the Rating (1=low 6=high) in Business regulatory environment in 2007 to that in 2013?
Ensure brevity in your answer.  1. What is the ratio of the Rating (1=low 6=high) in Debt policy in 2007 to that in 2013?
Provide a short and direct response. 0.88. What is the ratio of the Rating (1=low 6=high) of Management rating in 2007 to that in 2013?
Your response must be concise. 0.96. What is the ratio of the Rating (1=low 6=high) in Business regulatory environment in 2007 to that in 2014?
Offer a very short reply. 1. What is the ratio of the Rating (1=low 6=high) of Management rating in 2007 to that in 2014?
Your answer should be compact. 0.96. What is the ratio of the Rating (1=low 6=high) in Building human resources in 2008 to that in 2009?
Provide a short and direct response. 1. What is the ratio of the Rating (1=low 6=high) of Business regulatory environment in 2008 to that in 2009?
Your answer should be compact. 1. What is the ratio of the Rating (1=low 6=high) in Debt policy in 2008 to that in 2009?
Provide a succinct answer. 1. What is the ratio of the Rating (1=low 6=high) in Management rating in 2008 to that in 2009?
Keep it short and to the point. 0.99. What is the ratio of the Rating (1=low 6=high) in Business regulatory environment in 2008 to that in 2010?
Keep it short and to the point. 1. What is the ratio of the Rating (1=low 6=high) of Building human resources in 2008 to that in 2011?
Your answer should be compact. 0.88. What is the ratio of the Rating (1=low 6=high) in Management rating in 2008 to that in 2011?
Provide a succinct answer. 0.99. What is the ratio of the Rating (1=low 6=high) of Building human resources in 2008 to that in 2012?
Give a very brief answer. 0.88. What is the ratio of the Rating (1=low 6=high) in Debt policy in 2008 to that in 2012?
Ensure brevity in your answer.  0.88. What is the ratio of the Rating (1=low 6=high) in Business regulatory environment in 2008 to that in 2013?
Give a very brief answer. 1. What is the ratio of the Rating (1=low 6=high) of Debt policy in 2008 to that in 2013?
Your answer should be very brief. 0.88. What is the ratio of the Rating (1=low 6=high) of Building human resources in 2008 to that in 2014?
Make the answer very short. 0.88. What is the ratio of the Rating (1=low 6=high) of Business regulatory environment in 2008 to that in 2014?
Offer a very short reply. 1. What is the ratio of the Rating (1=low 6=high) of Management rating in 2008 to that in 2014?
Offer a terse response. 0.99. What is the ratio of the Rating (1=low 6=high) of Business regulatory environment in 2009 to that in 2010?
Your answer should be compact. 1. What is the ratio of the Rating (1=low 6=high) in Debt policy in 2009 to that in 2010?
Your answer should be very brief. 1. What is the ratio of the Rating (1=low 6=high) in Management rating in 2009 to that in 2010?
Your answer should be very brief. 0.96. What is the ratio of the Rating (1=low 6=high) of Building human resources in 2009 to that in 2011?
Your answer should be compact. 0.88. What is the ratio of the Rating (1=low 6=high) of Management rating in 2009 to that in 2011?
Offer a terse response. 1. What is the ratio of the Rating (1=low 6=high) of Building human resources in 2009 to that in 2012?
Provide a succinct answer. 0.88. What is the ratio of the Rating (1=low 6=high) of Business regulatory environment in 2009 to that in 2012?
Give a very brief answer. 1. What is the ratio of the Rating (1=low 6=high) of Debt policy in 2009 to that in 2012?
Give a very brief answer. 0.88. What is the ratio of the Rating (1=low 6=high) of Management rating in 2009 to that in 2012?
Your answer should be compact. 1. What is the ratio of the Rating (1=low 6=high) of Building human resources in 2009 to that in 2013?
Provide a succinct answer. 0.88. What is the ratio of the Rating (1=low 6=high) in Business regulatory environment in 2009 to that in 2013?
Make the answer very short. 1. What is the ratio of the Rating (1=low 6=high) of Debt policy in 2009 to that in 2013?
Give a very brief answer. 0.88. What is the ratio of the Rating (1=low 6=high) in Business regulatory environment in 2009 to that in 2014?
Provide a succinct answer. 1. What is the ratio of the Rating (1=low 6=high) in Building human resources in 2010 to that in 2011?
Your answer should be very brief. 0.88. What is the ratio of the Rating (1=low 6=high) of Management rating in 2010 to that in 2011?
Provide a short and direct response. 1.04. What is the ratio of the Rating (1=low 6=high) in Building human resources in 2010 to that in 2012?
Your answer should be very brief. 0.88. What is the ratio of the Rating (1=low 6=high) of Management rating in 2010 to that in 2012?
Your answer should be compact. 1.04. What is the ratio of the Rating (1=low 6=high) in Building human resources in 2010 to that in 2013?
Offer a very short reply. 0.88. What is the ratio of the Rating (1=low 6=high) in Management rating in 2010 to that in 2013?
Provide a succinct answer. 1.04. What is the ratio of the Rating (1=low 6=high) in Building human resources in 2010 to that in 2014?
Offer a terse response. 0.88. What is the ratio of the Rating (1=low 6=high) of Business regulatory environment in 2010 to that in 2014?
Keep it short and to the point. 1. What is the ratio of the Rating (1=low 6=high) of Management rating in 2010 to that in 2014?
Your answer should be compact. 1.04. What is the ratio of the Rating (1=low 6=high) of Business regulatory environment in 2011 to that in 2012?
Your response must be concise. 1. What is the ratio of the Rating (1=low 6=high) in Debt policy in 2011 to that in 2012?
Make the answer very short. 0.88. What is the ratio of the Rating (1=low 6=high) in Business regulatory environment in 2011 to that in 2013?
Ensure brevity in your answer.  1. What is the ratio of the Rating (1=low 6=high) in Management rating in 2011 to that in 2013?
Ensure brevity in your answer.  1. What is the ratio of the Rating (1=low 6=high) in Business regulatory environment in 2011 to that in 2014?
Ensure brevity in your answer.  1. What is the ratio of the Rating (1=low 6=high) of Management rating in 2011 to that in 2014?
Offer a terse response. 1. What is the ratio of the Rating (1=low 6=high) of Business regulatory environment in 2012 to that in 2013?
Provide a succinct answer. 1. What is the ratio of the Rating (1=low 6=high) in Debt policy in 2012 to that in 2013?
Your response must be concise. 1. What is the ratio of the Rating (1=low 6=high) of Building human resources in 2012 to that in 2014?
Ensure brevity in your answer.  1. What is the ratio of the Rating (1=low 6=high) of Business regulatory environment in 2012 to that in 2014?
Ensure brevity in your answer.  1. What is the ratio of the Rating (1=low 6=high) in Debt policy in 2012 to that in 2014?
Offer a very short reply. 1. What is the ratio of the Rating (1=low 6=high) in Debt policy in 2013 to that in 2014?
Provide a succinct answer. 1. What is the ratio of the Rating (1=low 6=high) of Management rating in 2013 to that in 2014?
Your response must be concise. 1. What is the difference between the highest and the second highest Rating (1=low 6=high) in Management rating?
Your answer should be very brief. 0.17. 